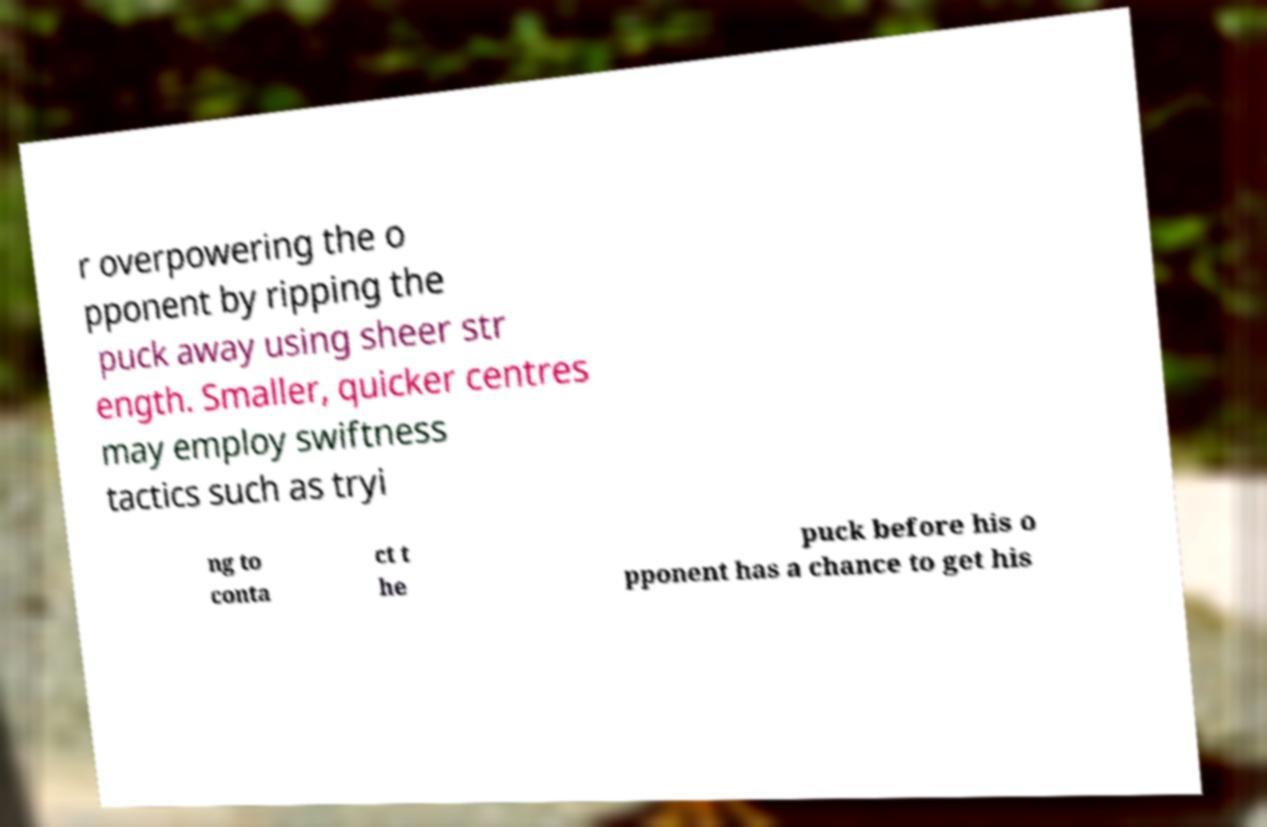For documentation purposes, I need the text within this image transcribed. Could you provide that? r overpowering the o pponent by ripping the puck away using sheer str ength. Smaller, quicker centres may employ swiftness tactics such as tryi ng to conta ct t he puck before his o pponent has a chance to get his 